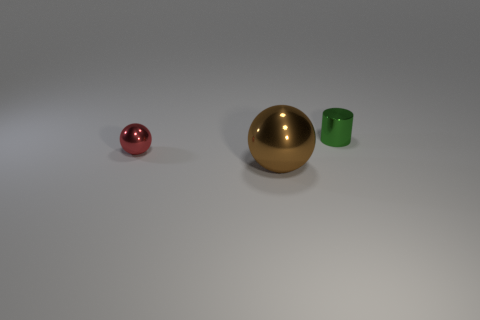Add 2 red things. How many objects exist? 5 Subtract all cylinders. How many objects are left? 2 Subtract 0 red cylinders. How many objects are left? 3 Subtract all green metal objects. Subtract all metal cubes. How many objects are left? 2 Add 2 small red metal objects. How many small red metal objects are left? 3 Add 1 tiny cylinders. How many tiny cylinders exist? 2 